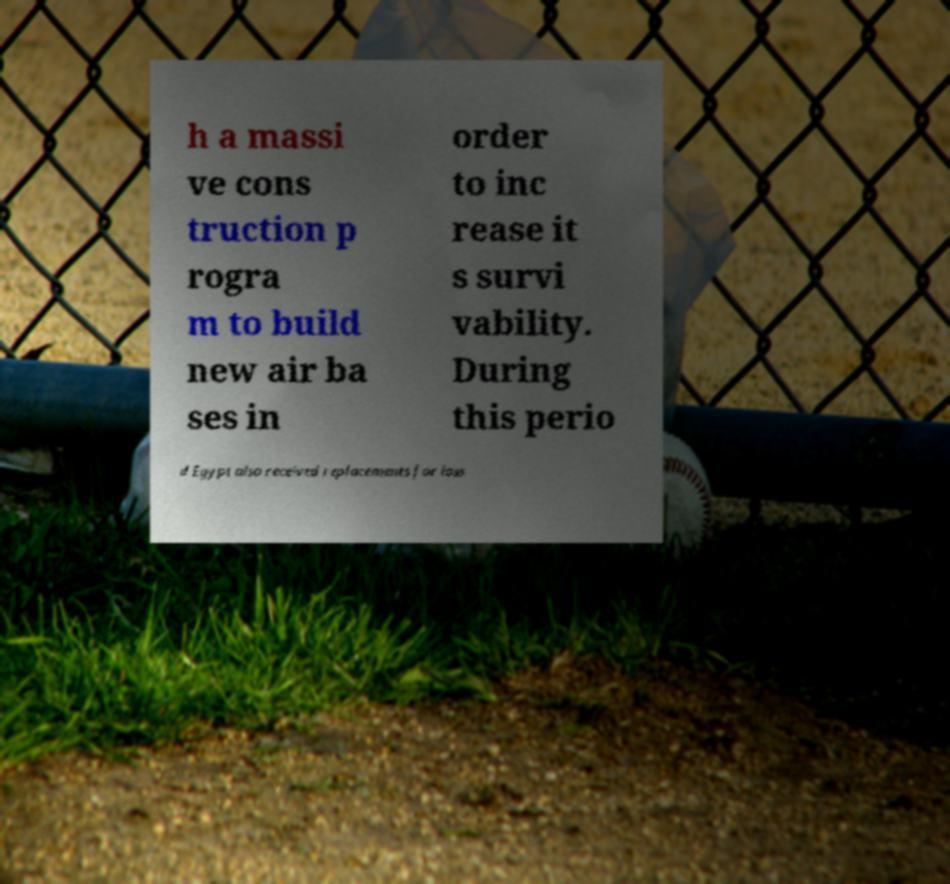Can you accurately transcribe the text from the provided image for me? h a massi ve cons truction p rogra m to build new air ba ses in order to inc rease it s survi vability. During this perio d Egypt also received replacements for loss 